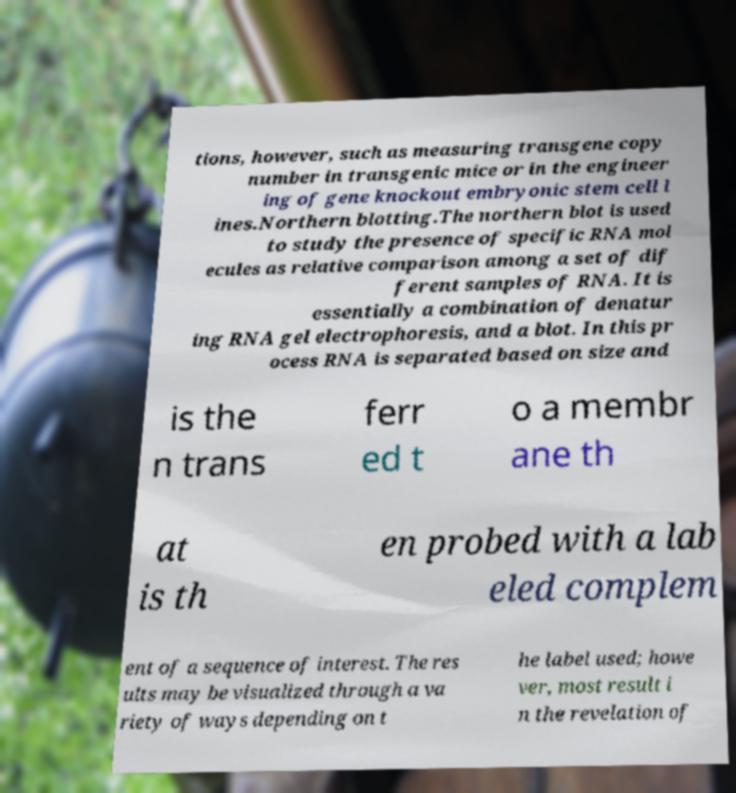Can you read and provide the text displayed in the image?This photo seems to have some interesting text. Can you extract and type it out for me? tions, however, such as measuring transgene copy number in transgenic mice or in the engineer ing of gene knockout embryonic stem cell l ines.Northern blotting.The northern blot is used to study the presence of specific RNA mol ecules as relative comparison among a set of dif ferent samples of RNA. It is essentially a combination of denatur ing RNA gel electrophoresis, and a blot. In this pr ocess RNA is separated based on size and is the n trans ferr ed t o a membr ane th at is th en probed with a lab eled complem ent of a sequence of interest. The res ults may be visualized through a va riety of ways depending on t he label used; howe ver, most result i n the revelation of 